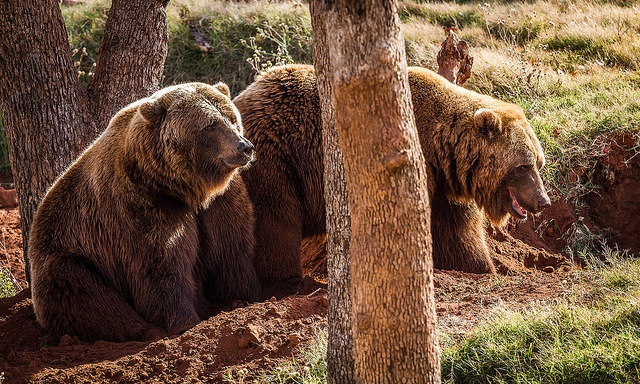Describe the objects in this image and their specific colors. I can see bear in black, maroon, and gray tones and bear in black, maroon, and brown tones in this image. 